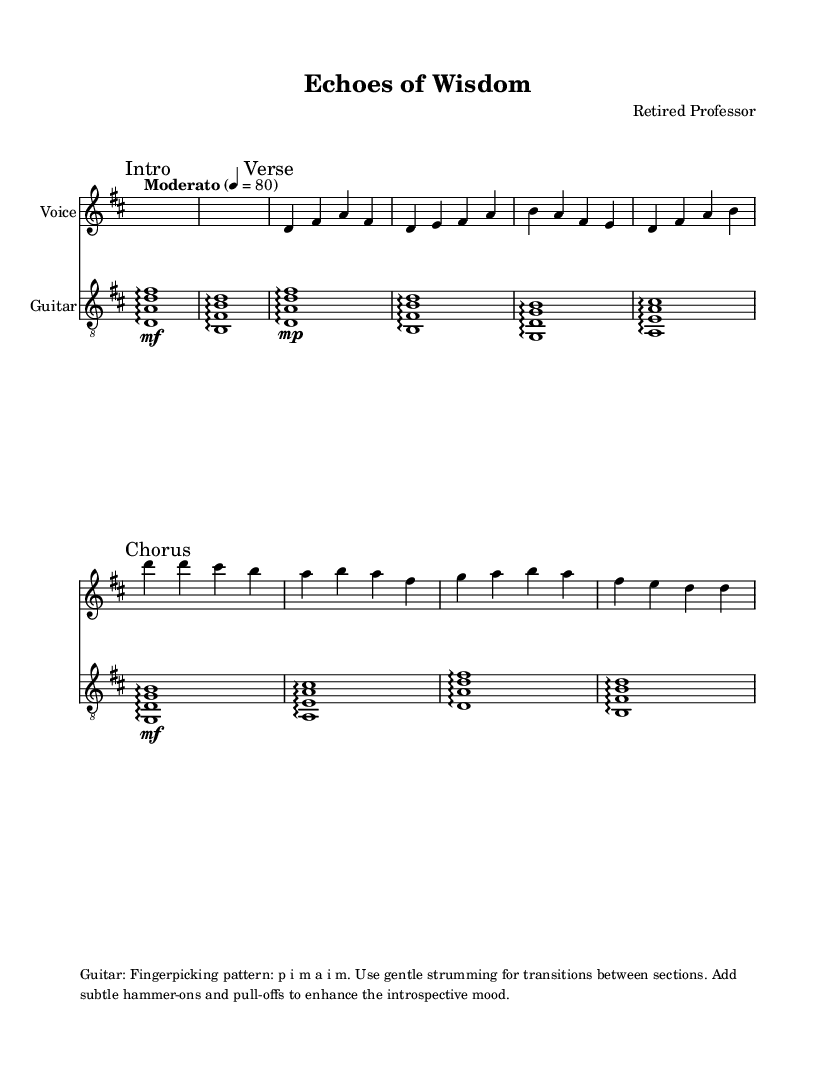What is the key signature of this music? The key signature is two sharps, which corresponds to D major. This is indicated at the beginning of the score.
Answer: D major What is the time signature of this music? The time signature is indicated as 4/4 at the beginning of the score, meaning there are four beats per measure.
Answer: 4/4 What is the tempo marking for this piece? The tempo marking is "Moderato," which indicates a moderate pace for the music. This is also specified at the start of the score.
Answer: Moderato What dynamic markings are found in the verse? The verse contains a dynamic marking of "down" (indicating a softer volume) and is followed by a measure to signify the change in dynamics for the voice part.
Answer: Dynamic down How many measures are there in the chorus? The chorus consists of four measures, as counted from the start to the end of this vocal section in the music score.
Answer: Four measures What kind of picking pattern is suggested for the guitar? The notation indicates a fingerpicking pattern of "p i m a i m," which means to use the thumb, index, middle, and ring fingers in succession.
Answer: p i m a i m What emotion or theme is conveyed by the lyrics in the verse? The lyrics in the verse reflect themes of sharing knowledge and preparing young minds, suggesting an introspective and reflective tone.
Answer: Introspective 